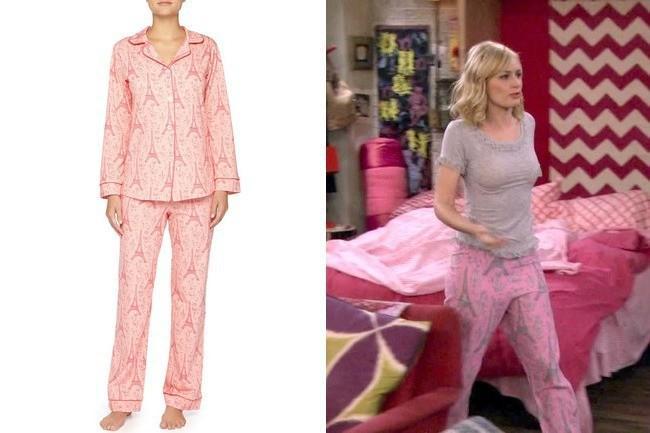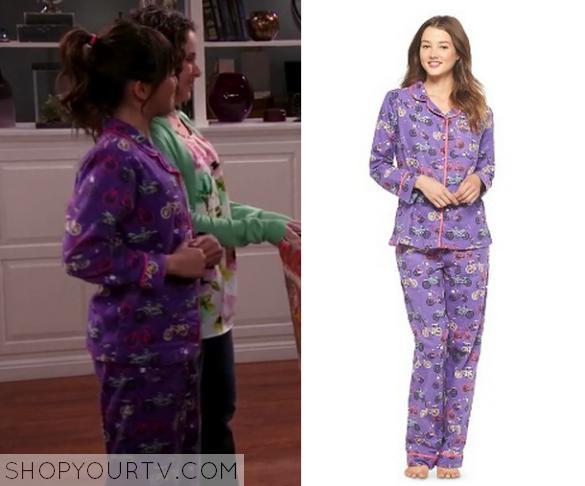The first image is the image on the left, the second image is the image on the right. Assess this claim about the two images: "There is at least 1 person facing right in the right image.". Correct or not? Answer yes or no. Yes. 